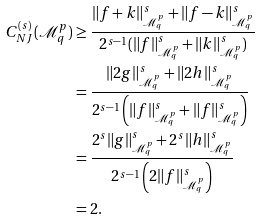<formula> <loc_0><loc_0><loc_500><loc_500>C _ { N J } ^ { ( s ) } ( \mathcal { M } ^ { p } _ { q } ) & \geq \frac { \| f + k \| ^ { s } _ { \mathcal { M } ^ { p } _ { q } } + \| f - k \| ^ { s } _ { \mathcal { M } ^ { p } _ { q } } } { 2 ^ { s - 1 } ( \| f \| ^ { s } _ { \mathcal { M } ^ { p } _ { q } } + \| k \| ^ { s } _ { \mathcal { M } ^ { p } _ { q } } ) } \\ & = \frac { \| 2 g \| ^ { s } _ { \mathcal { M } ^ { p } _ { q } } + \| 2 h \| ^ { s } _ { \mathcal { M } ^ { p } _ { q } } } { 2 ^ { s - 1 } \left ( \| f \| ^ { s } _ { \mathcal { M } ^ { p } _ { q } } + \| f \| ^ { s } _ { \mathcal { M } ^ { p } _ { q } } \right ) } \\ & = \frac { 2 ^ { s } \| g \| ^ { s } _ { \mathcal { M } ^ { p } _ { q } } + 2 ^ { s } \| h \| ^ { s } _ { \mathcal { M } ^ { p } _ { q } } } { 2 ^ { s - 1 } \left ( 2 \| f \| ^ { s } _ { \mathcal { M } ^ { p } _ { q } } \right ) } \\ & = 2 .</formula> 